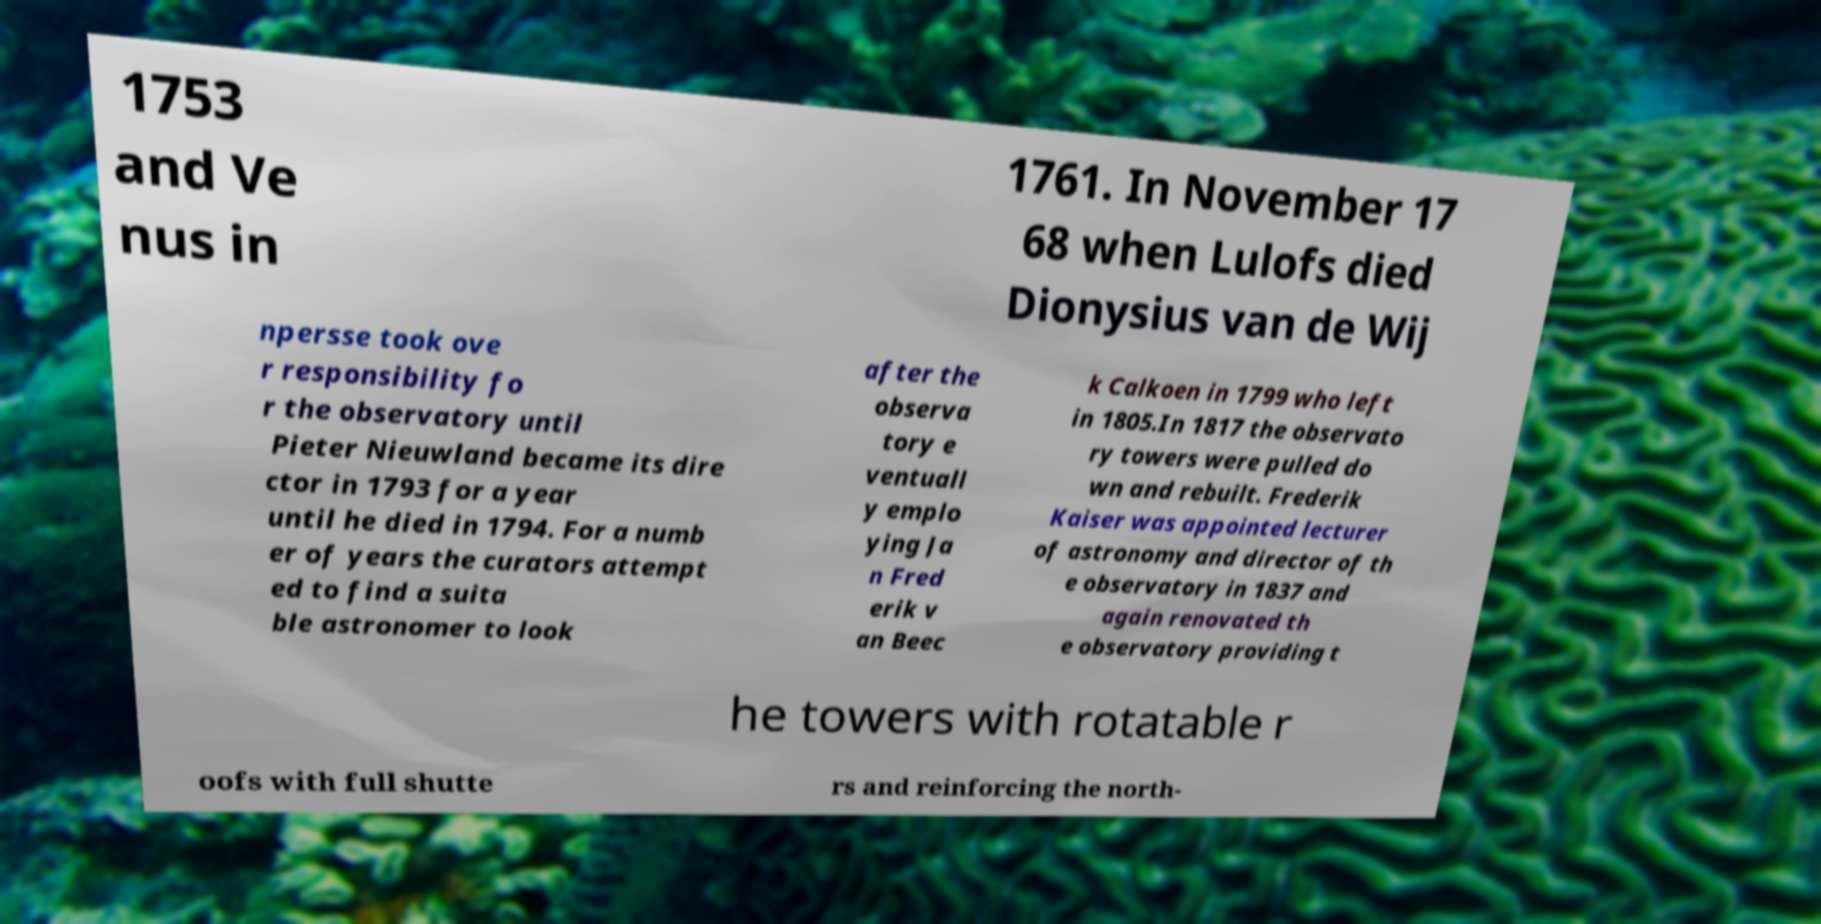Could you extract and type out the text from this image? 1753 and Ve nus in 1761. In November 17 68 when Lulofs died Dionysius van de Wij npersse took ove r responsibility fo r the observatory until Pieter Nieuwland became its dire ctor in 1793 for a year until he died in 1794. For a numb er of years the curators attempt ed to find a suita ble astronomer to look after the observa tory e ventuall y emplo ying Ja n Fred erik v an Beec k Calkoen in 1799 who left in 1805.In 1817 the observato ry towers were pulled do wn and rebuilt. Frederik Kaiser was appointed lecturer of astronomy and director of th e observatory in 1837 and again renovated th e observatory providing t he towers with rotatable r oofs with full shutte rs and reinforcing the north- 